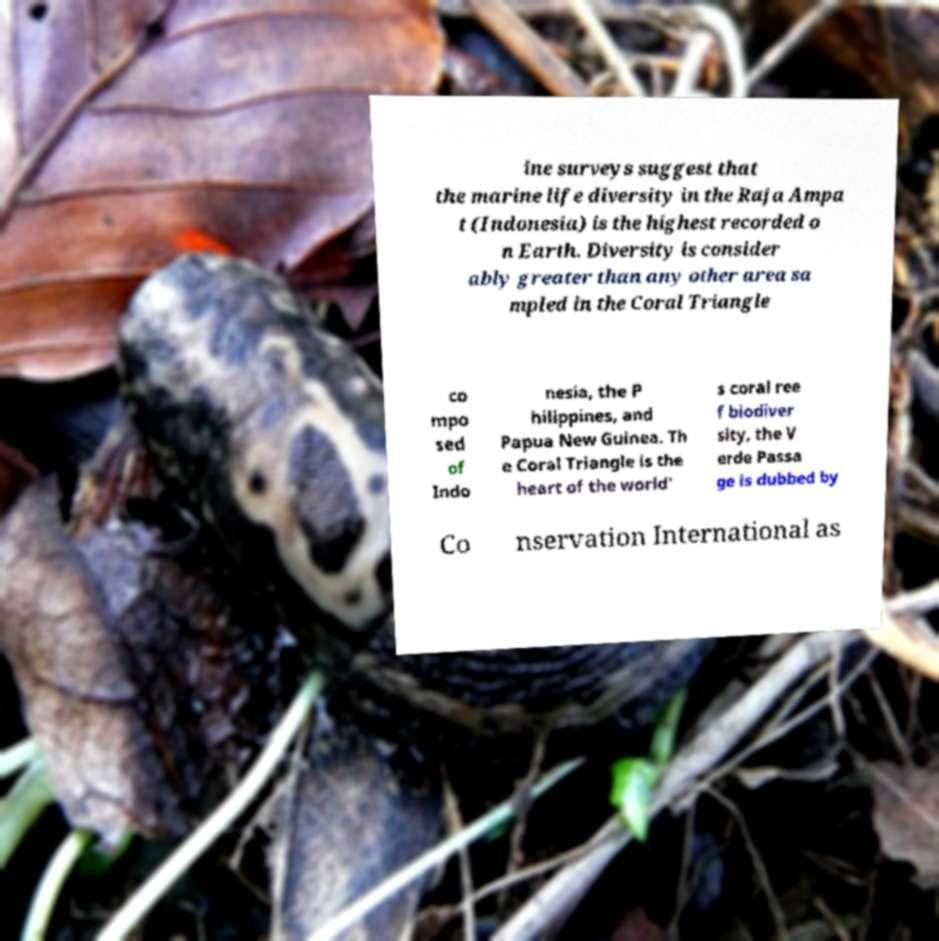Please read and relay the text visible in this image. What does it say? ine surveys suggest that the marine life diversity in the Raja Ampa t (Indonesia) is the highest recorded o n Earth. Diversity is consider ably greater than any other area sa mpled in the Coral Triangle co mpo sed of Indo nesia, the P hilippines, and Papua New Guinea. Th e Coral Triangle is the heart of the world' s coral ree f biodiver sity, the V erde Passa ge is dubbed by Co nservation International as 